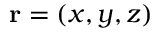Convert formula to latex. <formula><loc_0><loc_0><loc_500><loc_500>{ r } = ( x , y , z )</formula> 